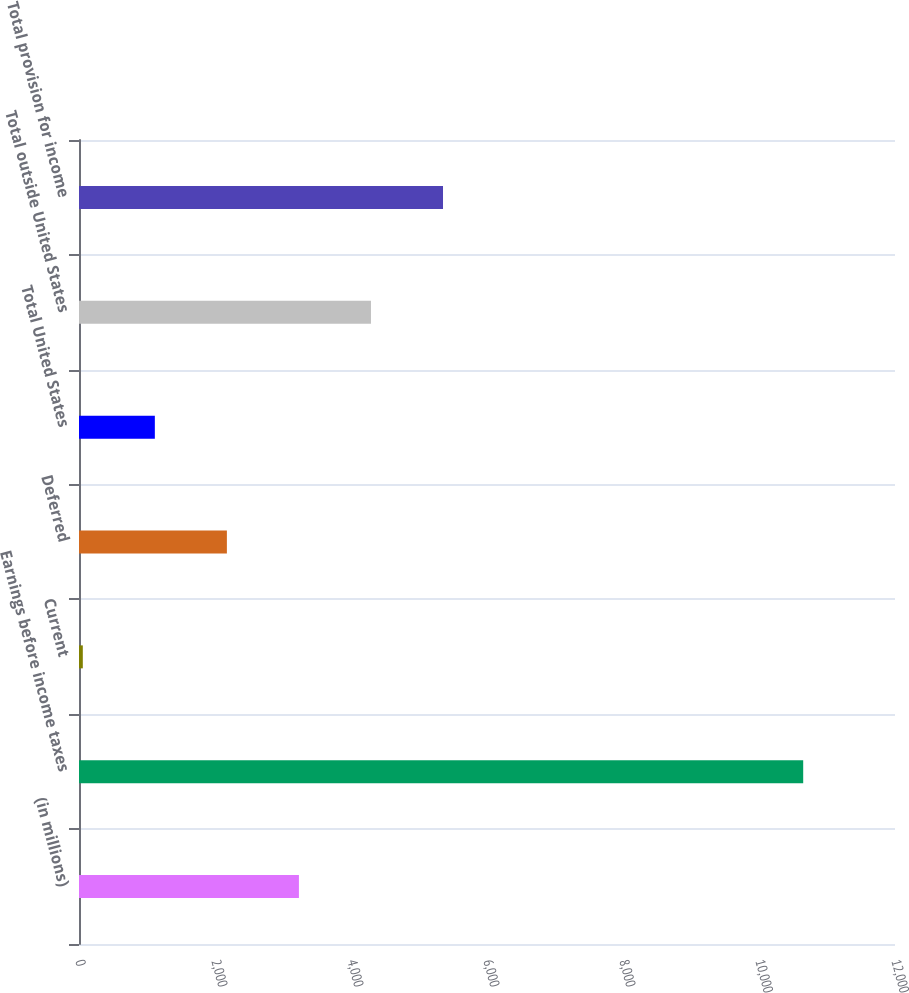Convert chart. <chart><loc_0><loc_0><loc_500><loc_500><bar_chart><fcel>(in millions)<fcel>Earnings before income taxes<fcel>Current<fcel>Deferred<fcel>Total United States<fcel>Total outside United States<fcel>Total provision for income<nl><fcel>3234.2<fcel>10650<fcel>56<fcel>2174.8<fcel>1115.4<fcel>4293.6<fcel>5353<nl></chart> 